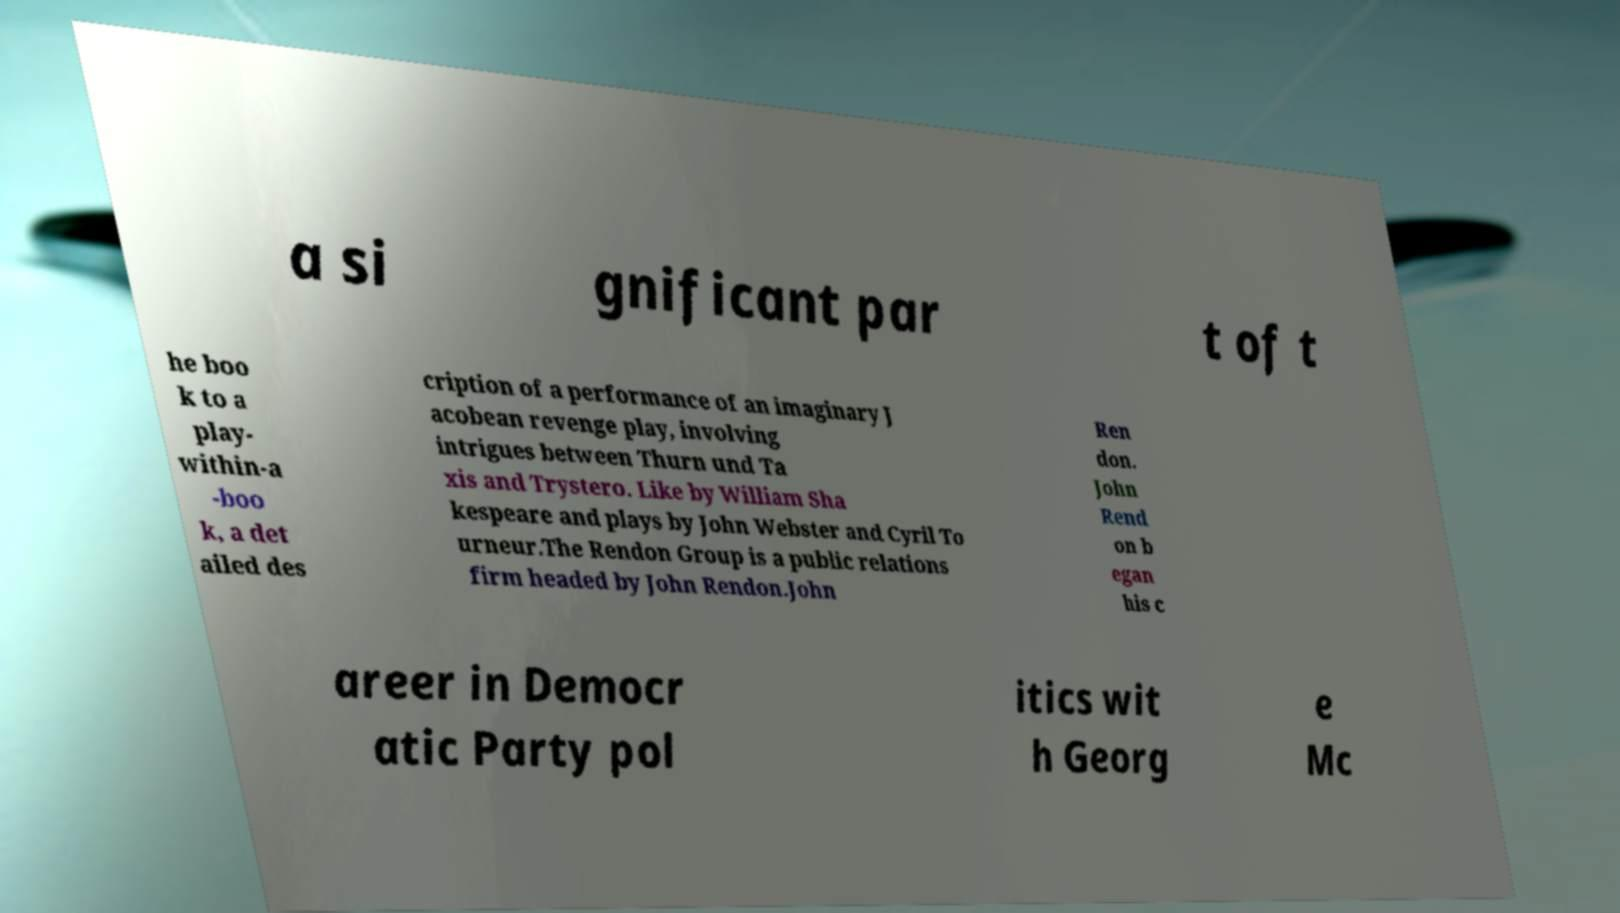Can you read and provide the text displayed in the image?This photo seems to have some interesting text. Can you extract and type it out for me? a si gnificant par t of t he boo k to a play- within-a -boo k, a det ailed des cription of a performance of an imaginary J acobean revenge play, involving intrigues between Thurn und Ta xis and Trystero. Like by William Sha kespeare and plays by John Webster and Cyril To urneur.The Rendon Group is a public relations firm headed by John Rendon.John Ren don. John Rend on b egan his c areer in Democr atic Party pol itics wit h Georg e Mc 